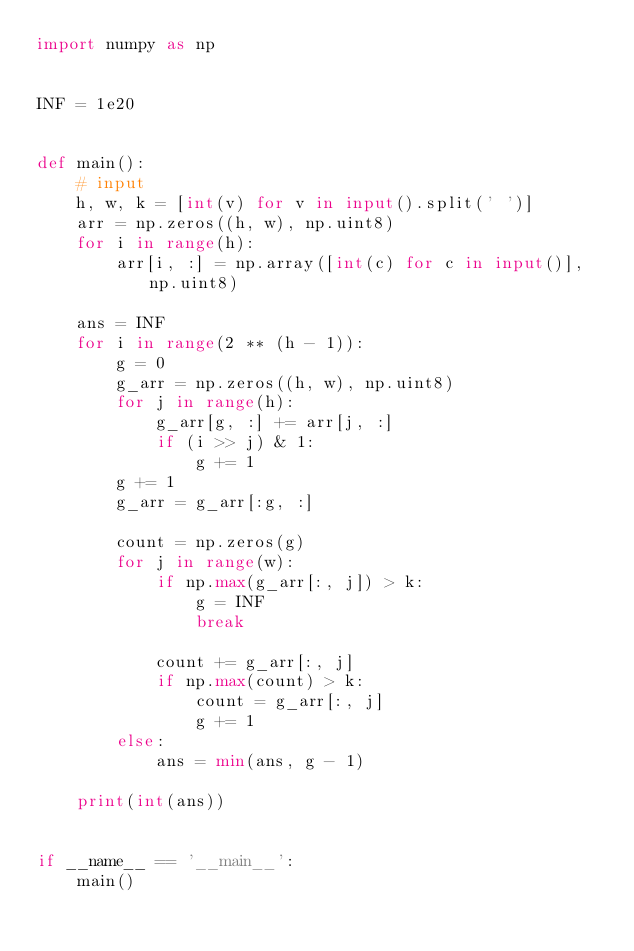Convert code to text. <code><loc_0><loc_0><loc_500><loc_500><_Python_>import numpy as np


INF = 1e20


def main():
    # input
    h, w, k = [int(v) for v in input().split(' ')]
    arr = np.zeros((h, w), np.uint8)
    for i in range(h):
        arr[i, :] = np.array([int(c) for c in input()], np.uint8)

    ans = INF
    for i in range(2 ** (h - 1)):
        g = 0
        g_arr = np.zeros((h, w), np.uint8)
        for j in range(h):
            g_arr[g, :] += arr[j, :]
            if (i >> j) & 1:
                g += 1
        g += 1
        g_arr = g_arr[:g, :]

        count = np.zeros(g)
        for j in range(w):
            if np.max(g_arr[:, j]) > k:
                g = INF
                break

            count += g_arr[:, j]
            if np.max(count) > k:
                count = g_arr[:, j]
                g += 1
        else:
            ans = min(ans, g - 1)

    print(int(ans))


if __name__ == '__main__':
    main()
</code> 